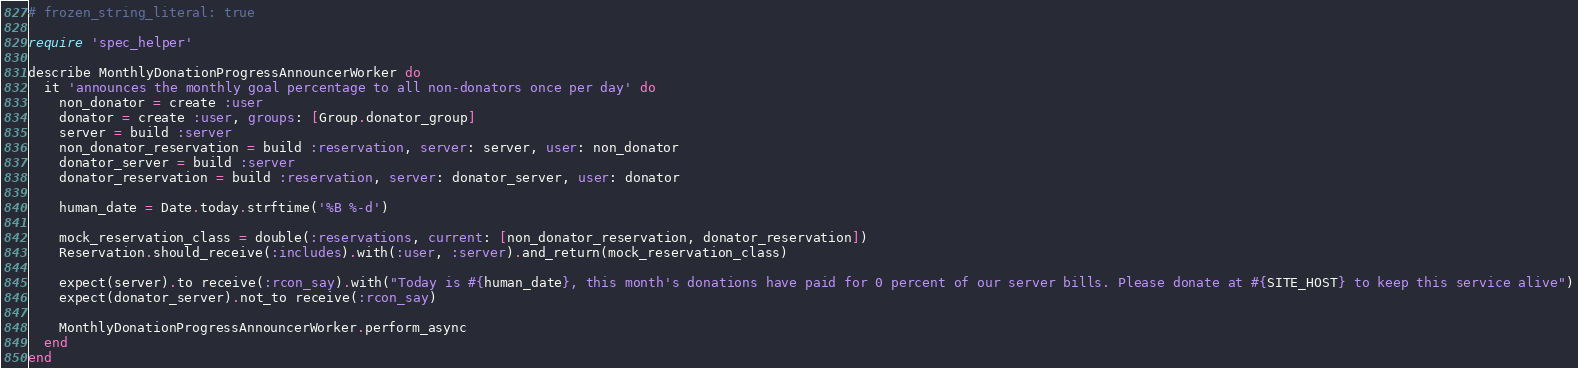Convert code to text. <code><loc_0><loc_0><loc_500><loc_500><_Ruby_># frozen_string_literal: true

require 'spec_helper'

describe MonthlyDonationProgressAnnouncerWorker do
  it 'announces the monthly goal percentage to all non-donators once per day' do
    non_donator = create :user
    donator = create :user, groups: [Group.donator_group]
    server = build :server
    non_donator_reservation = build :reservation, server: server, user: non_donator
    donator_server = build :server
    donator_reservation = build :reservation, server: donator_server, user: donator

    human_date = Date.today.strftime('%B %-d')

    mock_reservation_class = double(:reservations, current: [non_donator_reservation, donator_reservation])
    Reservation.should_receive(:includes).with(:user, :server).and_return(mock_reservation_class)

    expect(server).to receive(:rcon_say).with("Today is #{human_date}, this month's donations have paid for 0 percent of our server bills. Please donate at #{SITE_HOST} to keep this service alive")
    expect(donator_server).not_to receive(:rcon_say)

    MonthlyDonationProgressAnnouncerWorker.perform_async
  end
end
</code> 